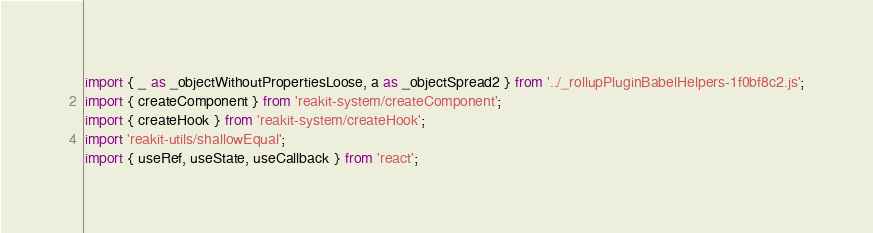<code> <loc_0><loc_0><loc_500><loc_500><_JavaScript_>import { _ as _objectWithoutPropertiesLoose, a as _objectSpread2 } from '../_rollupPluginBabelHelpers-1f0bf8c2.js';
import { createComponent } from 'reakit-system/createComponent';
import { createHook } from 'reakit-system/createHook';
import 'reakit-utils/shallowEqual';
import { useRef, useState, useCallback } from 'react';</code> 